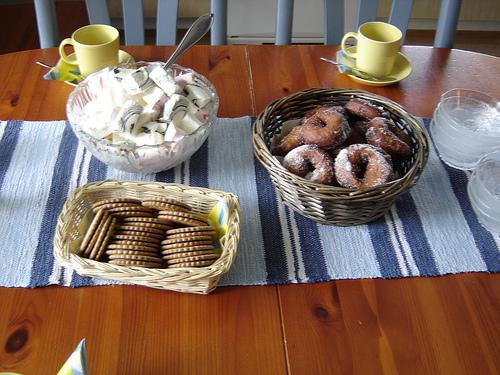Question: what color are the cups?
Choices:
A. Yellow.
B. Red.
C. Black.
D. Blue.
Answer with the letter. Answer: A Question: where are the chairs?
Choices:
A. Against the wall.
B. In a stack.
C. Still in the truck.
D. Behind the table.
Answer with the letter. Answer: D Question: how many chairs are at the table?
Choices:
A. 3.
B. 4.
C. 2.
D. 5.
Answer with the letter. Answer: C Question: why are there bowls?
Choices:
A. To hold the paint.
B. For food serving.
C. To hold the beads.
D. To give the pets their food.
Answer with the letter. Answer: B 